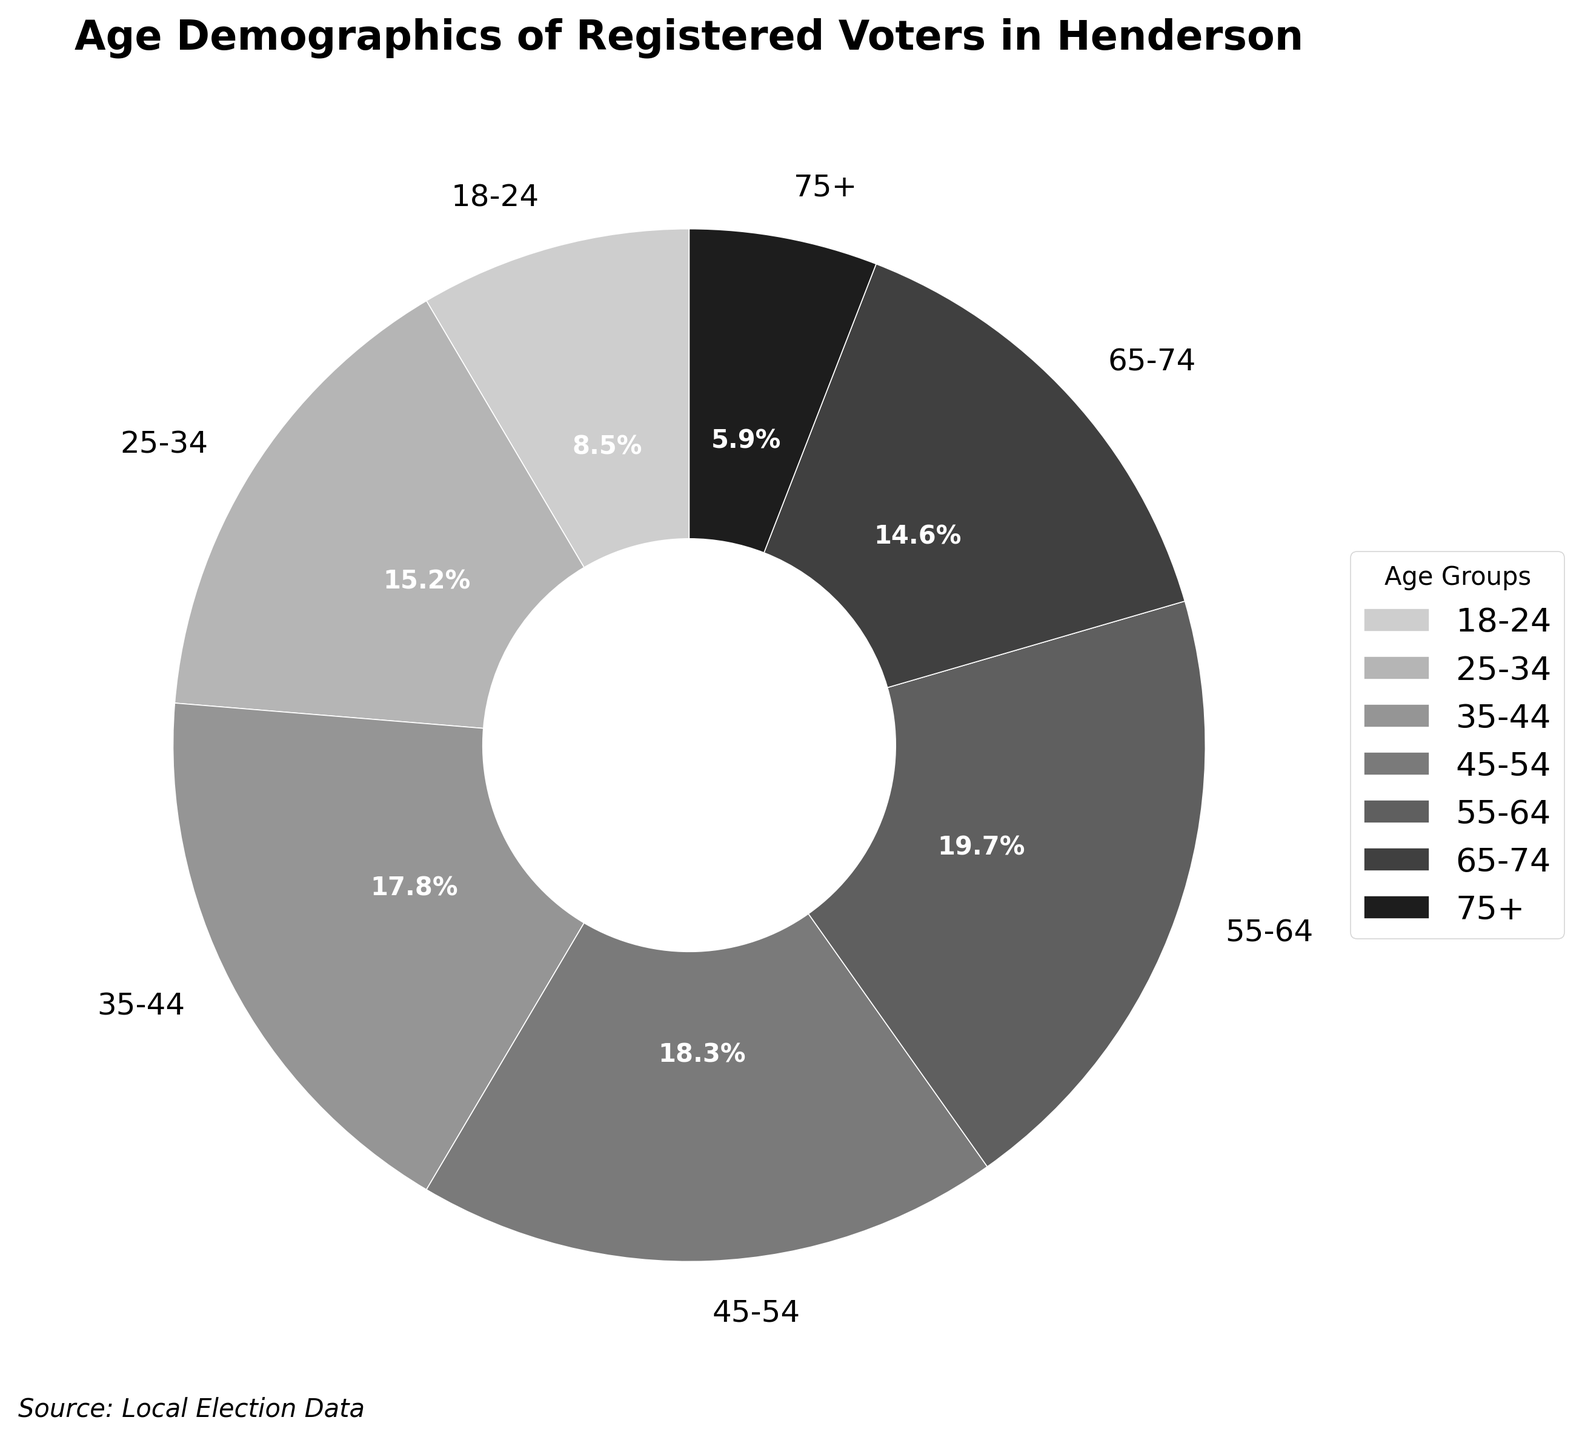What age group constitutes the largest percentage of registered voters? Look at the pie chart and identify the segment with the largest percentage label. The 55-64 age group has the largest segment, labeled at 19.7%.
Answer: 55-64 Which age groups have a percentage of registered voters greater than 15%? Check the pie chart for segments labeled with percentages above 15%. The age groups 25-34 (15.2%), 35-44 (17.8%), 45-54 (18.3%), and 55-64 (19.7%) all have percentages greater than 15%.
Answer: 25-34, 35-44, 45-54, 55-64 What is the combined percentage of registered voters aged 18-24 and 75+? Add the percentages of the 18-24 (8.5%) and 75+ (5.9%) age groups. 8.5% + 5.9% = 14.4%.
Answer: 14.4% How does the percentage of registered voters aged 65-74 compare to those aged 75+? Compare the percentages for the age groups 65-74 (14.6%) and 75+ (5.9%). The 65-74 age group has a higher percentage than the 75+ age group.
Answer: 65-74 is higher than 75+ How many age groups have less than 10% of registered voters? Identify segments in the pie chart with percentages below 10%. Only the 18-24 age group (8.5%) and the 75+ age group (5.9%) fall below 10%. There are two such age groups.
Answer: 2 What is the average percentage of registered voters for the age groups 25-34, 35-44, and 45-54? Add the percentages for the 25-34 (15.2%), 35-44 (17.8%), and 45-54 (18.3%) age groups and divide by three. (15.2 + 17.8 + 18.3) / 3 = 51.3 / 3 = 17.1%.
Answer: 17.1% Which age group is the second smallest in terms of percentage of registered voters? Check the pie chart for the segment labels and identify the second smallest percentage. The 18-24 age group is the smallest at 8.5%, and the next smallest is the 75+ age group at 5.9%.
Answer: 75+ What is the difference in percentage of registered voters between the 25-34 and 45-54 age groups? Subtract the percentage of the 25-34 age group (15.2%) from that of the 45-54 age group (18.3%). 18.3% - 15.2% = 3.1%.
Answer: 3.1% How does the percentage for the 55-64 age group visually compare to the percentage for the 45-54 age group in terms of segment size on the pie chart? Observe the segments corresponding to the 55-64 (19.7%) and 45-54 (18.3%) age groups on the pie chart. The 55-64 age group's segment is slightly larger than the 45-54 age group's segment.
Answer: 55-64 is larger than 45-54 